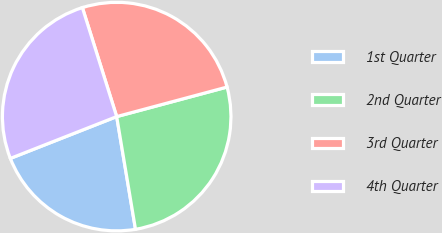Convert chart to OTSL. <chart><loc_0><loc_0><loc_500><loc_500><pie_chart><fcel>1st Quarter<fcel>2nd Quarter<fcel>3rd Quarter<fcel>4th Quarter<nl><fcel>21.67%<fcel>26.53%<fcel>25.69%<fcel>26.11%<nl></chart> 